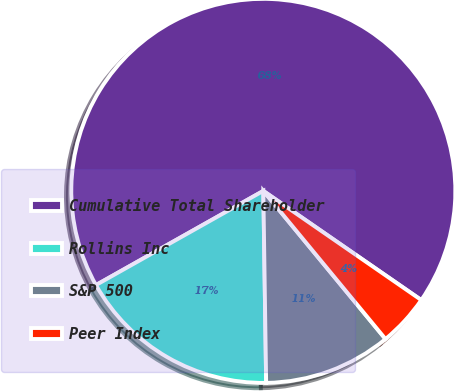Convert chart. <chart><loc_0><loc_0><loc_500><loc_500><pie_chart><fcel>Cumulative Total Shareholder<fcel>Rollins Inc<fcel>S&P 500<fcel>Peer Index<nl><fcel>67.78%<fcel>17.08%<fcel>10.74%<fcel>4.4%<nl></chart> 